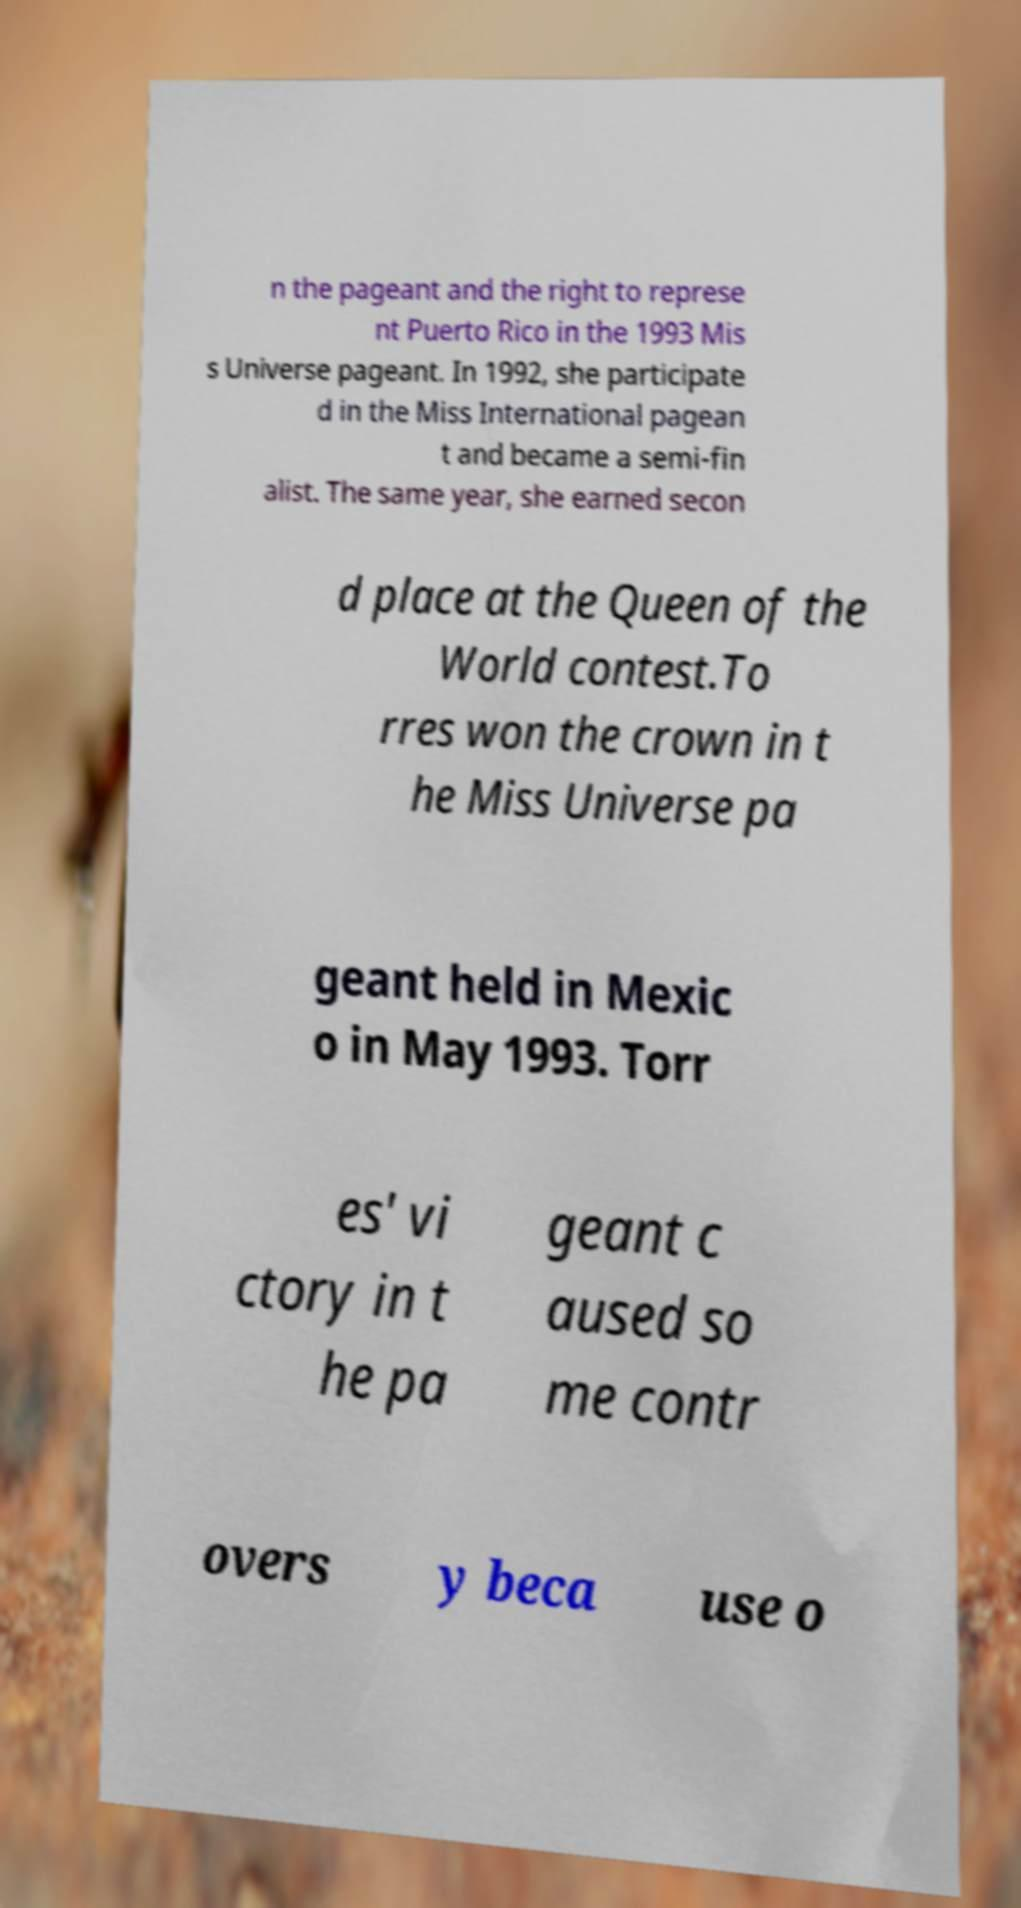Please read and relay the text visible in this image. What does it say? n the pageant and the right to represe nt Puerto Rico in the 1993 Mis s Universe pageant. In 1992, she participate d in the Miss International pagean t and became a semi-fin alist. The same year, she earned secon d place at the Queen of the World contest.To rres won the crown in t he Miss Universe pa geant held in Mexic o in May 1993. Torr es' vi ctory in t he pa geant c aused so me contr overs y beca use o 